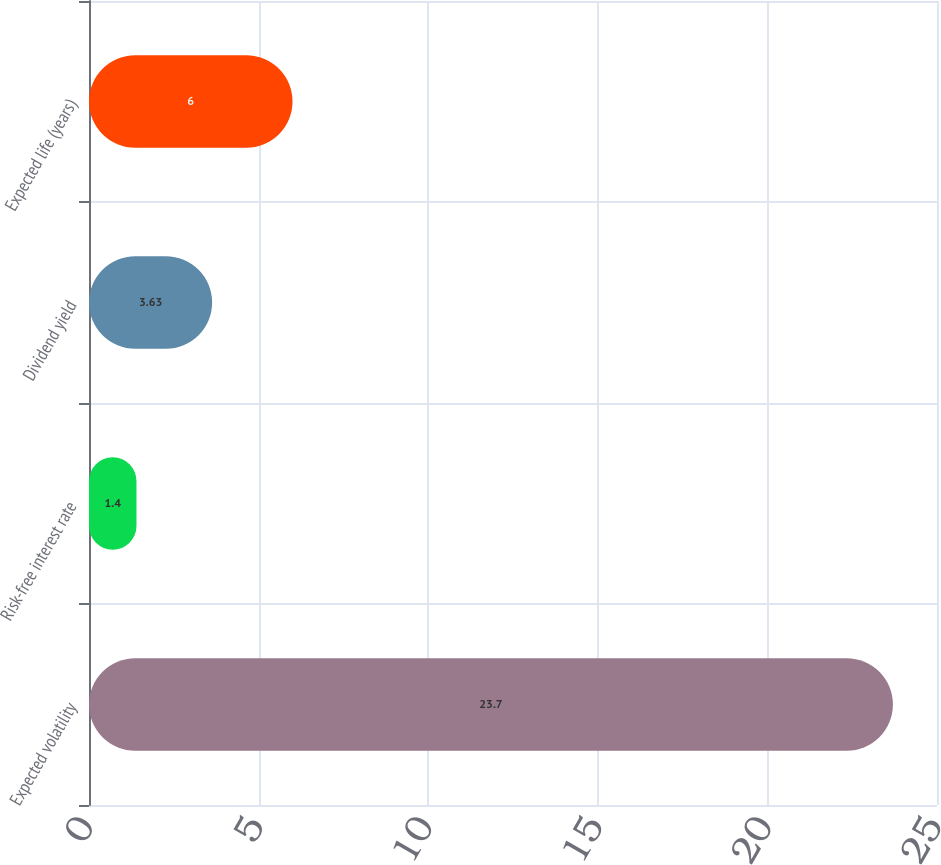Convert chart to OTSL. <chart><loc_0><loc_0><loc_500><loc_500><bar_chart><fcel>Expected volatility<fcel>Risk-free interest rate<fcel>Dividend yield<fcel>Expected life (years)<nl><fcel>23.7<fcel>1.4<fcel>3.63<fcel>6<nl></chart> 